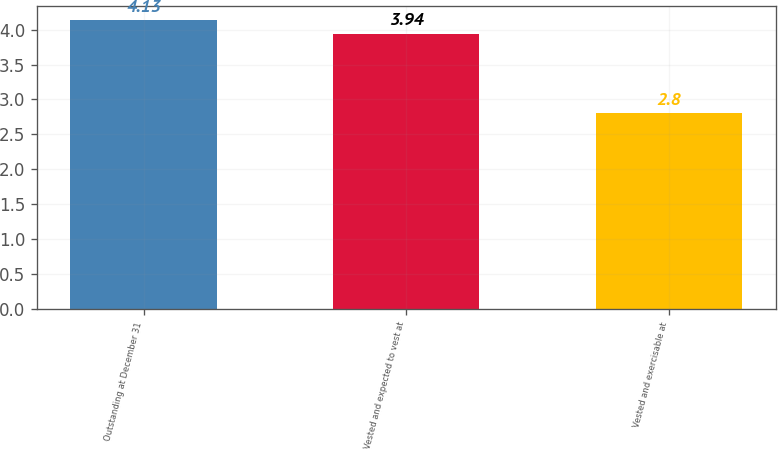<chart> <loc_0><loc_0><loc_500><loc_500><bar_chart><fcel>Outstanding at December 31<fcel>Vested and expected to vest at<fcel>Vested and exercisable at<nl><fcel>4.13<fcel>3.94<fcel>2.8<nl></chart> 